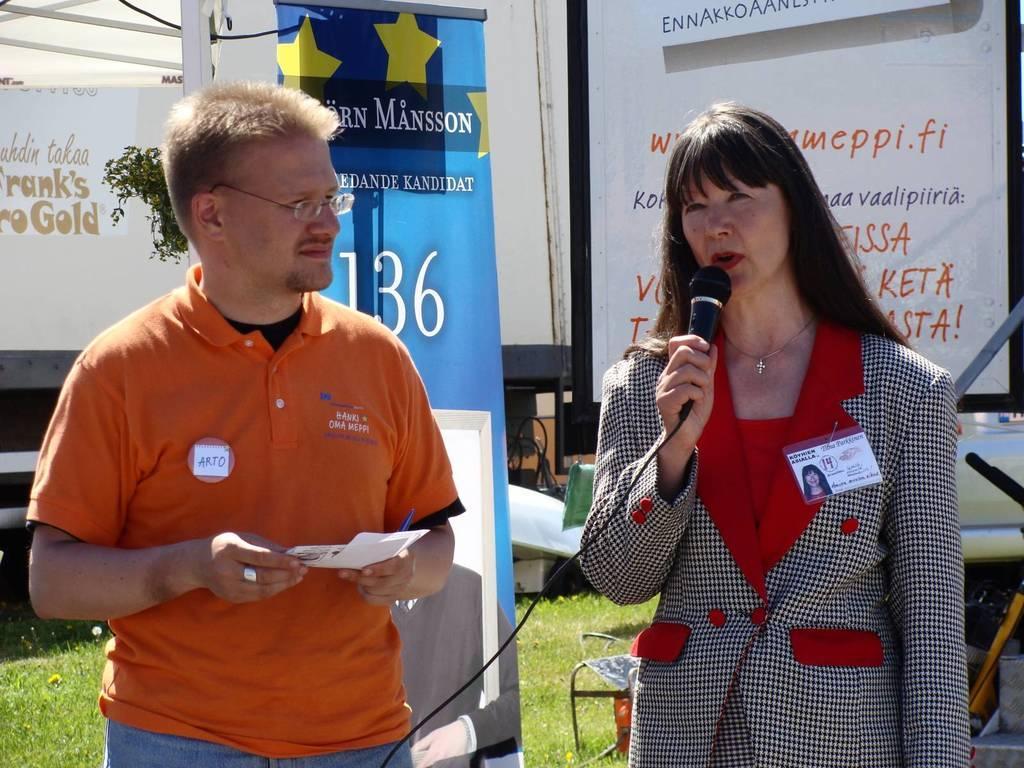Describe this image in one or two sentences. In this picture there is a man standing and holding a pen and paper in his hand. There is a woman standing and holding a mic in her hand. There is some grass on the ground. There are few posters and some objects at the background. 